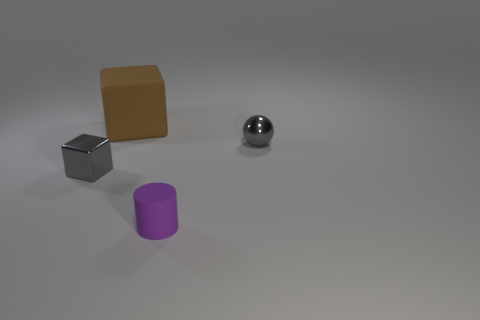Add 1 tiny purple metallic cubes. How many objects exist? 5 Subtract all balls. How many objects are left? 3 Subtract all tiny gray shiny things. Subtract all small gray balls. How many objects are left? 1 Add 4 small things. How many small things are left? 7 Add 3 green rubber objects. How many green rubber objects exist? 3 Subtract 0 green cubes. How many objects are left? 4 